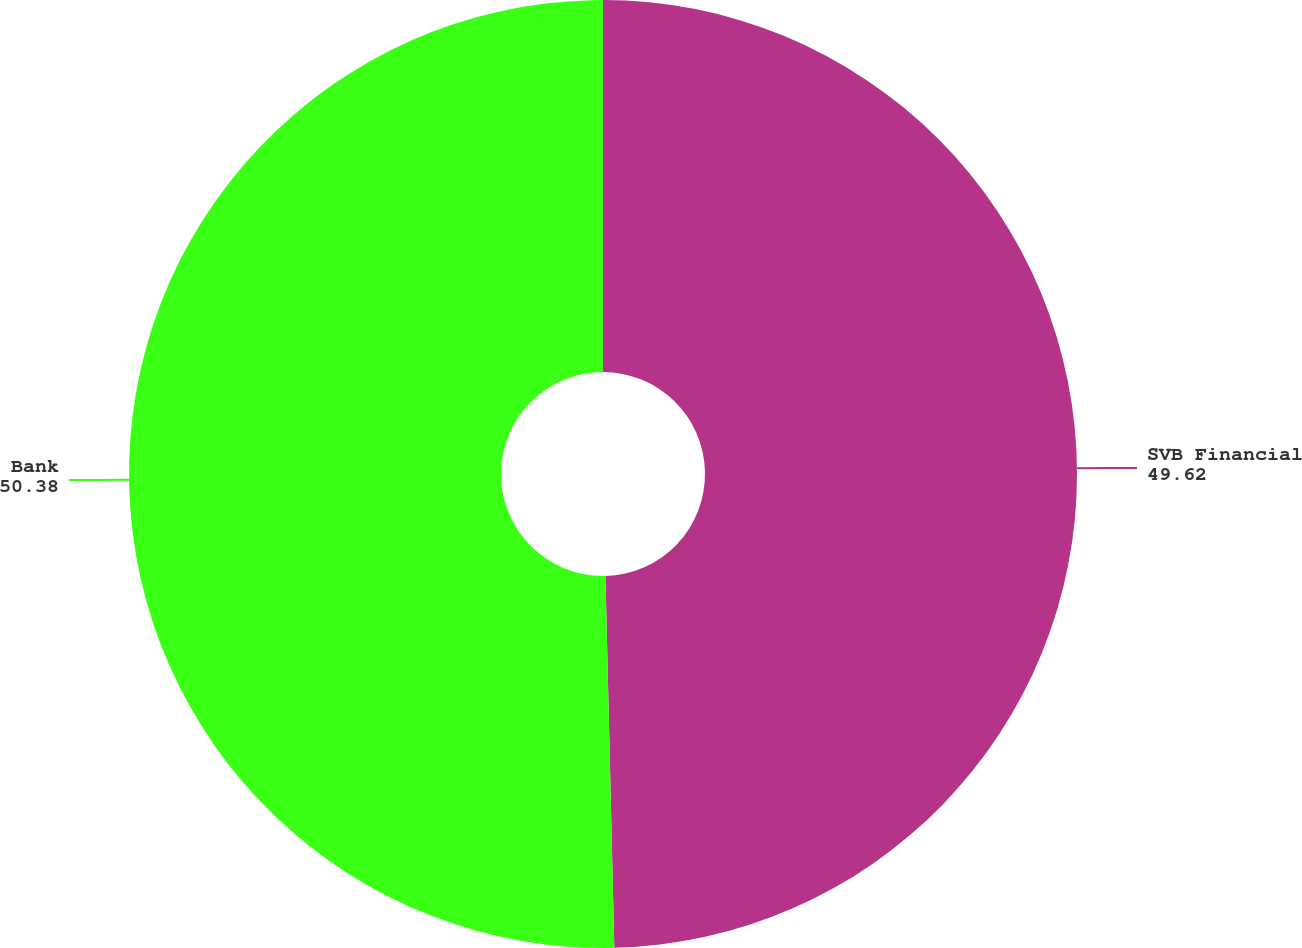<chart> <loc_0><loc_0><loc_500><loc_500><pie_chart><fcel>SVB Financial<fcel>Bank<nl><fcel>49.62%<fcel>50.38%<nl></chart> 